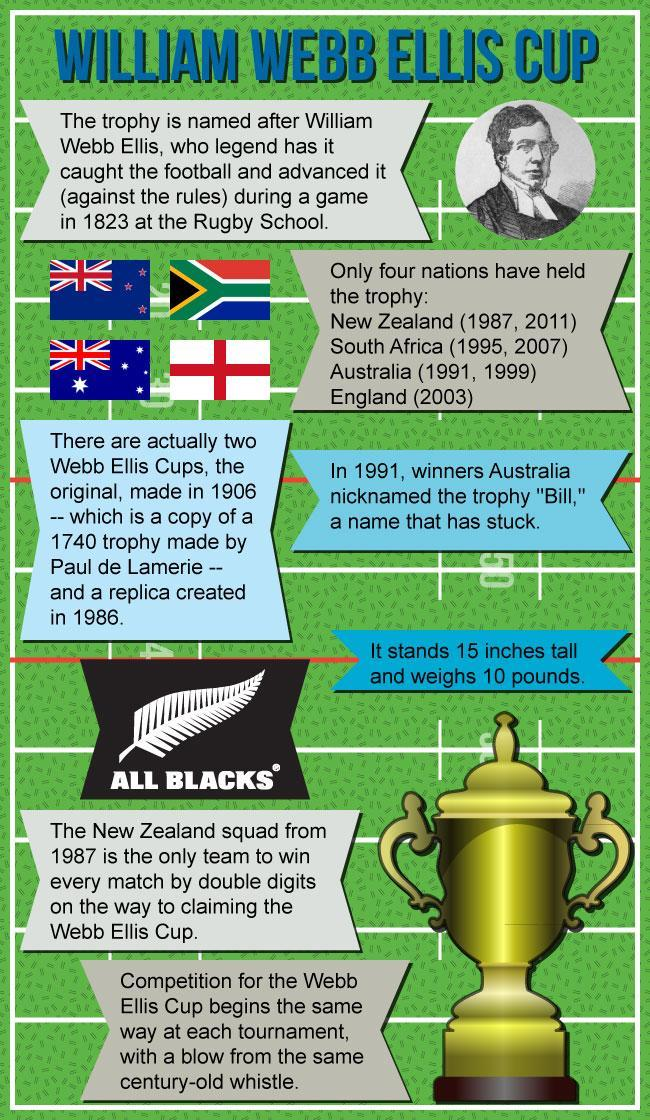Which country has won the Webb Ellis cup only once?
Answer the question with a short phrase. England What is the name of the squad that scored two digit victory in all matches? All Blacks When were replicas of the Web Ellis cup made, 1906, 1991,1740, or 1986? 1906, 1986 